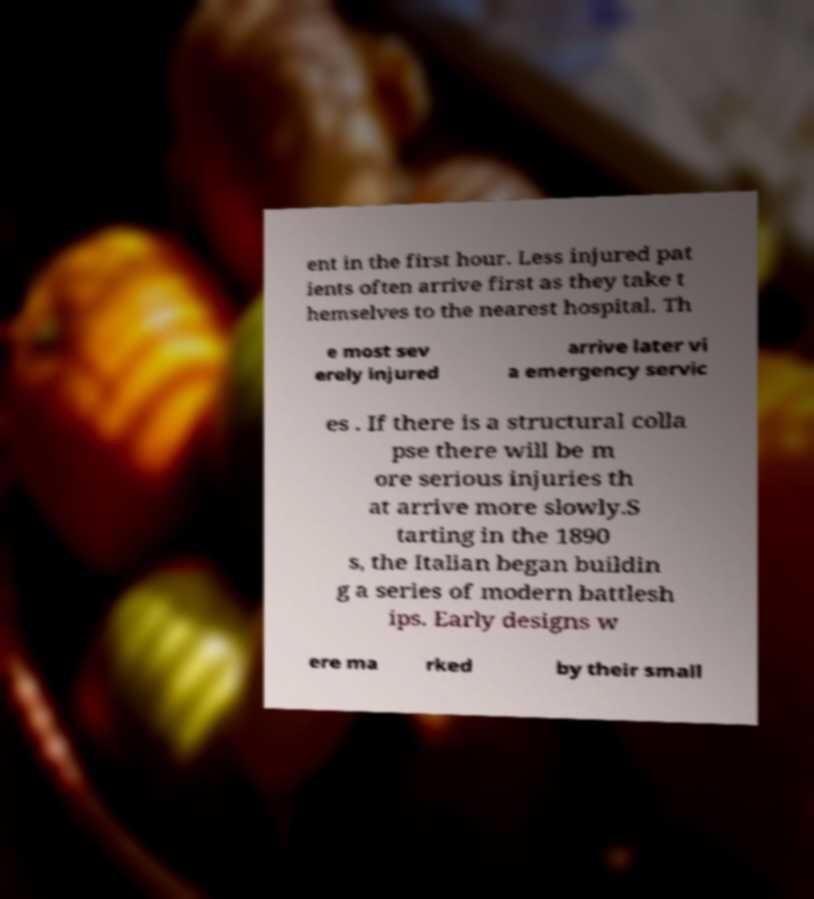Please read and relay the text visible in this image. What does it say? ent in the first hour. Less injured pat ients often arrive first as they take t hemselves to the nearest hospital. Th e most sev erely injured arrive later vi a emergency servic es . If there is a structural colla pse there will be m ore serious injuries th at arrive more slowly.S tarting in the 1890 s, the Italian began buildin g a series of modern battlesh ips. Early designs w ere ma rked by their small 